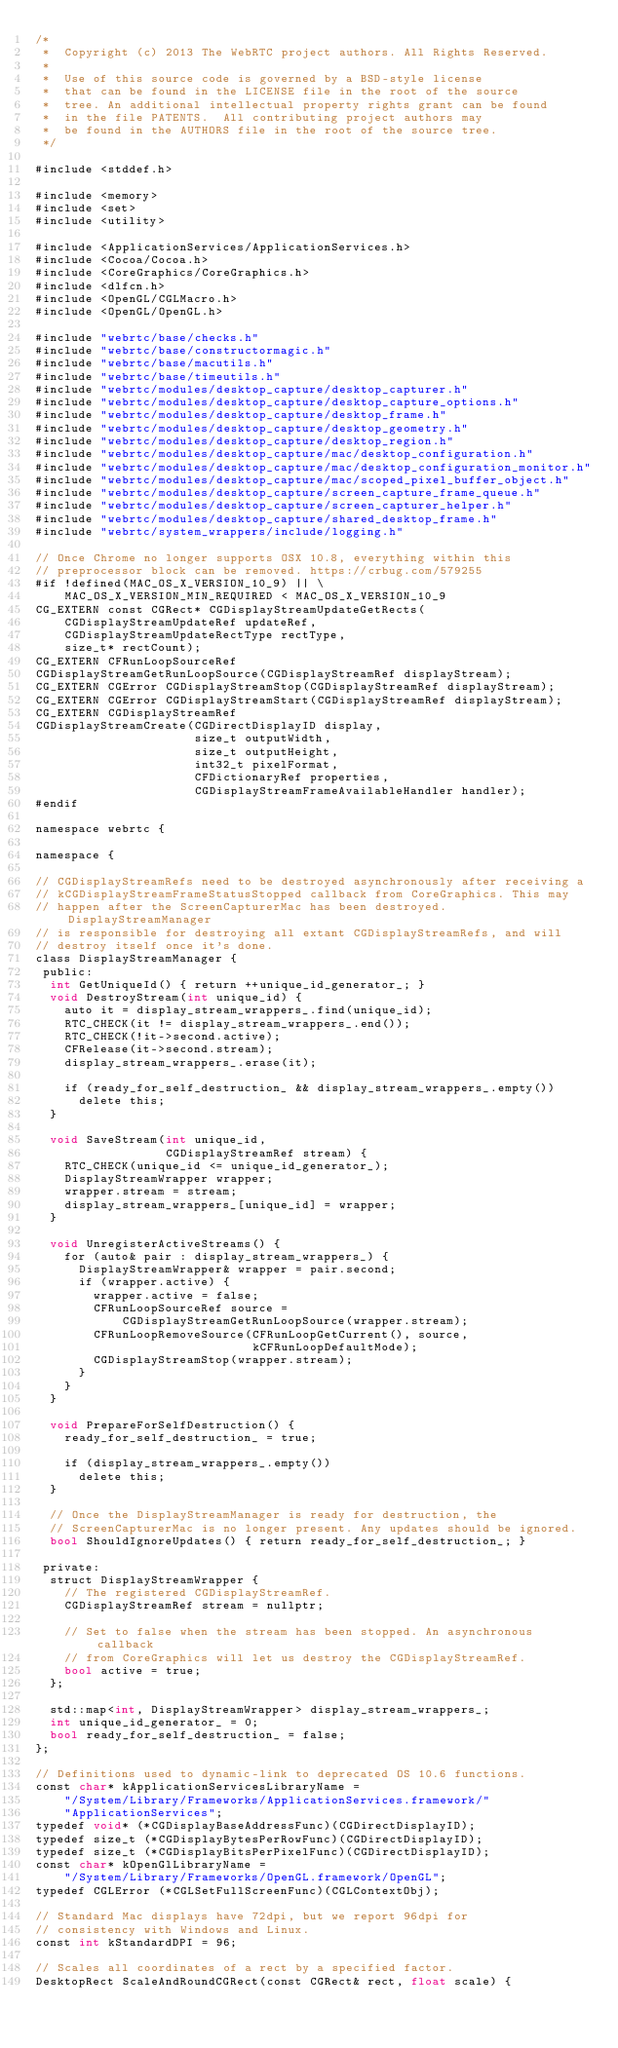<code> <loc_0><loc_0><loc_500><loc_500><_ObjectiveC_>/*
 *  Copyright (c) 2013 The WebRTC project authors. All Rights Reserved.
 *
 *  Use of this source code is governed by a BSD-style license
 *  that can be found in the LICENSE file in the root of the source
 *  tree. An additional intellectual property rights grant can be found
 *  in the file PATENTS.  All contributing project authors may
 *  be found in the AUTHORS file in the root of the source tree.
 */

#include <stddef.h>

#include <memory>
#include <set>
#include <utility>

#include <ApplicationServices/ApplicationServices.h>
#include <Cocoa/Cocoa.h>
#include <CoreGraphics/CoreGraphics.h>
#include <dlfcn.h>
#include <OpenGL/CGLMacro.h>
#include <OpenGL/OpenGL.h>

#include "webrtc/base/checks.h"
#include "webrtc/base/constructormagic.h"
#include "webrtc/base/macutils.h"
#include "webrtc/base/timeutils.h"
#include "webrtc/modules/desktop_capture/desktop_capturer.h"
#include "webrtc/modules/desktop_capture/desktop_capture_options.h"
#include "webrtc/modules/desktop_capture/desktop_frame.h"
#include "webrtc/modules/desktop_capture/desktop_geometry.h"
#include "webrtc/modules/desktop_capture/desktop_region.h"
#include "webrtc/modules/desktop_capture/mac/desktop_configuration.h"
#include "webrtc/modules/desktop_capture/mac/desktop_configuration_monitor.h"
#include "webrtc/modules/desktop_capture/mac/scoped_pixel_buffer_object.h"
#include "webrtc/modules/desktop_capture/screen_capture_frame_queue.h"
#include "webrtc/modules/desktop_capture/screen_capturer_helper.h"
#include "webrtc/modules/desktop_capture/shared_desktop_frame.h"
#include "webrtc/system_wrappers/include/logging.h"

// Once Chrome no longer supports OSX 10.8, everything within this
// preprocessor block can be removed. https://crbug.com/579255
#if !defined(MAC_OS_X_VERSION_10_9) || \
    MAC_OS_X_VERSION_MIN_REQUIRED < MAC_OS_X_VERSION_10_9
CG_EXTERN const CGRect* CGDisplayStreamUpdateGetRects(
    CGDisplayStreamUpdateRef updateRef,
    CGDisplayStreamUpdateRectType rectType,
    size_t* rectCount);
CG_EXTERN CFRunLoopSourceRef
CGDisplayStreamGetRunLoopSource(CGDisplayStreamRef displayStream);
CG_EXTERN CGError CGDisplayStreamStop(CGDisplayStreamRef displayStream);
CG_EXTERN CGError CGDisplayStreamStart(CGDisplayStreamRef displayStream);
CG_EXTERN CGDisplayStreamRef
CGDisplayStreamCreate(CGDirectDisplayID display,
                      size_t outputWidth,
                      size_t outputHeight,
                      int32_t pixelFormat,
                      CFDictionaryRef properties,
                      CGDisplayStreamFrameAvailableHandler handler);
#endif

namespace webrtc {

namespace {

// CGDisplayStreamRefs need to be destroyed asynchronously after receiving a
// kCGDisplayStreamFrameStatusStopped callback from CoreGraphics. This may
// happen after the ScreenCapturerMac has been destroyed. DisplayStreamManager
// is responsible for destroying all extant CGDisplayStreamRefs, and will
// destroy itself once it's done.
class DisplayStreamManager {
 public:
  int GetUniqueId() { return ++unique_id_generator_; }
  void DestroyStream(int unique_id) {
    auto it = display_stream_wrappers_.find(unique_id);
    RTC_CHECK(it != display_stream_wrappers_.end());
    RTC_CHECK(!it->second.active);
    CFRelease(it->second.stream);
    display_stream_wrappers_.erase(it);

    if (ready_for_self_destruction_ && display_stream_wrappers_.empty())
      delete this;
  }

  void SaveStream(int unique_id,
                  CGDisplayStreamRef stream) {
    RTC_CHECK(unique_id <= unique_id_generator_);
    DisplayStreamWrapper wrapper;
    wrapper.stream = stream;
    display_stream_wrappers_[unique_id] = wrapper;
  }

  void UnregisterActiveStreams() {
    for (auto& pair : display_stream_wrappers_) {
      DisplayStreamWrapper& wrapper = pair.second;
      if (wrapper.active) {
        wrapper.active = false;
        CFRunLoopSourceRef source =
            CGDisplayStreamGetRunLoopSource(wrapper.stream);
        CFRunLoopRemoveSource(CFRunLoopGetCurrent(), source,
                              kCFRunLoopDefaultMode);
        CGDisplayStreamStop(wrapper.stream);
      }
    }
  }

  void PrepareForSelfDestruction() {
    ready_for_self_destruction_ = true;

    if (display_stream_wrappers_.empty())
      delete this;
  }

  // Once the DisplayStreamManager is ready for destruction, the
  // ScreenCapturerMac is no longer present. Any updates should be ignored.
  bool ShouldIgnoreUpdates() { return ready_for_self_destruction_; }

 private:
  struct DisplayStreamWrapper {
    // The registered CGDisplayStreamRef.
    CGDisplayStreamRef stream = nullptr;

    // Set to false when the stream has been stopped. An asynchronous callback
    // from CoreGraphics will let us destroy the CGDisplayStreamRef.
    bool active = true;
  };

  std::map<int, DisplayStreamWrapper> display_stream_wrappers_;
  int unique_id_generator_ = 0;
  bool ready_for_self_destruction_ = false;
};

// Definitions used to dynamic-link to deprecated OS 10.6 functions.
const char* kApplicationServicesLibraryName =
    "/System/Library/Frameworks/ApplicationServices.framework/"
    "ApplicationServices";
typedef void* (*CGDisplayBaseAddressFunc)(CGDirectDisplayID);
typedef size_t (*CGDisplayBytesPerRowFunc)(CGDirectDisplayID);
typedef size_t (*CGDisplayBitsPerPixelFunc)(CGDirectDisplayID);
const char* kOpenGlLibraryName =
    "/System/Library/Frameworks/OpenGL.framework/OpenGL";
typedef CGLError (*CGLSetFullScreenFunc)(CGLContextObj);

// Standard Mac displays have 72dpi, but we report 96dpi for
// consistency with Windows and Linux.
const int kStandardDPI = 96;

// Scales all coordinates of a rect by a specified factor.
DesktopRect ScaleAndRoundCGRect(const CGRect& rect, float scale) {</code> 